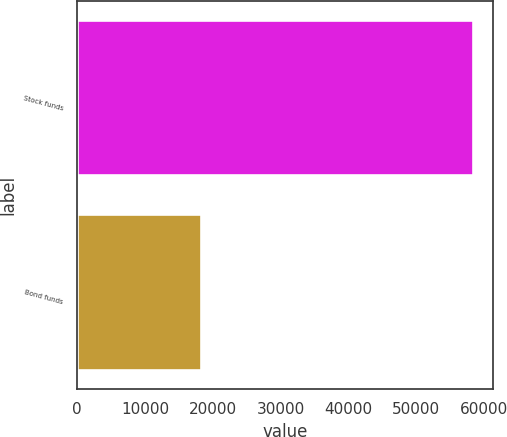<chart> <loc_0><loc_0><loc_500><loc_500><bar_chart><fcel>Stock funds<fcel>Bond funds<nl><fcel>58324<fcel>18290<nl></chart> 